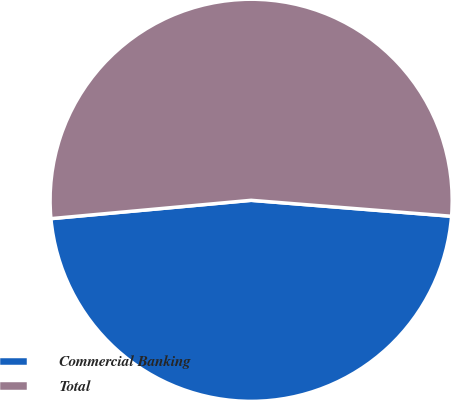<chart> <loc_0><loc_0><loc_500><loc_500><pie_chart><fcel>Commercial Banking<fcel>Total<nl><fcel>47.28%<fcel>52.72%<nl></chart> 